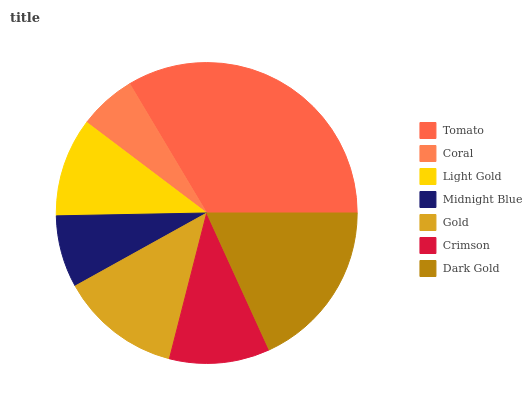Is Coral the minimum?
Answer yes or no. Yes. Is Tomato the maximum?
Answer yes or no. Yes. Is Light Gold the minimum?
Answer yes or no. No. Is Light Gold the maximum?
Answer yes or no. No. Is Light Gold greater than Coral?
Answer yes or no. Yes. Is Coral less than Light Gold?
Answer yes or no. Yes. Is Coral greater than Light Gold?
Answer yes or no. No. Is Light Gold less than Coral?
Answer yes or no. No. Is Crimson the high median?
Answer yes or no. Yes. Is Crimson the low median?
Answer yes or no. Yes. Is Dark Gold the high median?
Answer yes or no. No. Is Dark Gold the low median?
Answer yes or no. No. 